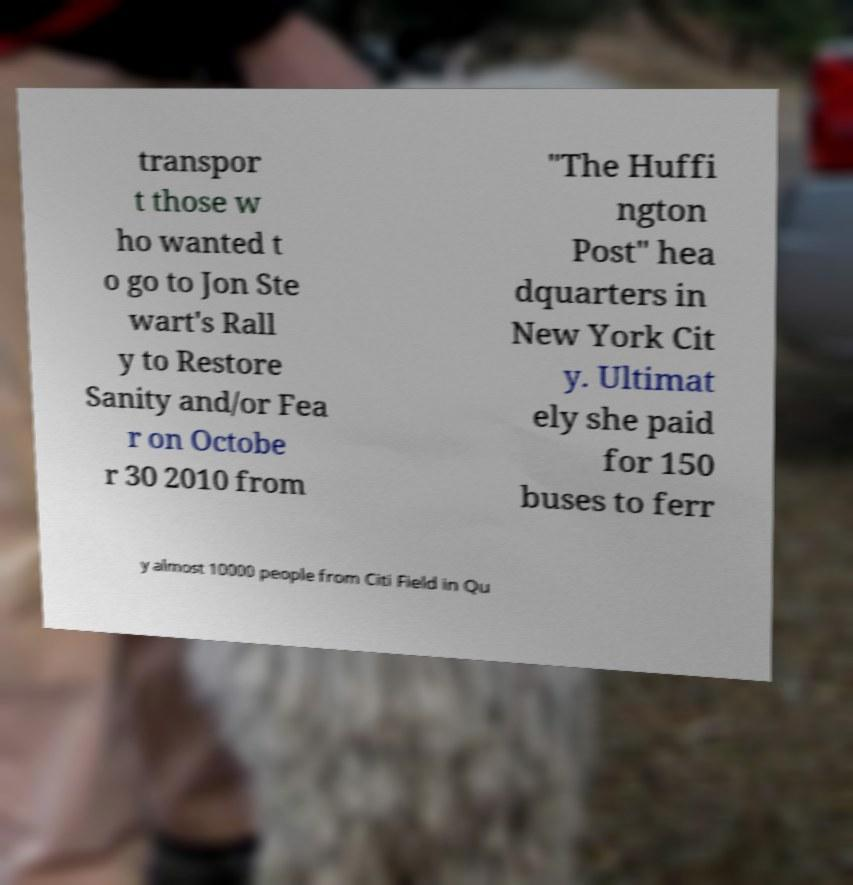Please identify and transcribe the text found in this image. transpor t those w ho wanted t o go to Jon Ste wart's Rall y to Restore Sanity and/or Fea r on Octobe r 30 2010 from "The Huffi ngton Post" hea dquarters in New York Cit y. Ultimat ely she paid for 150 buses to ferr y almost 10000 people from Citi Field in Qu 